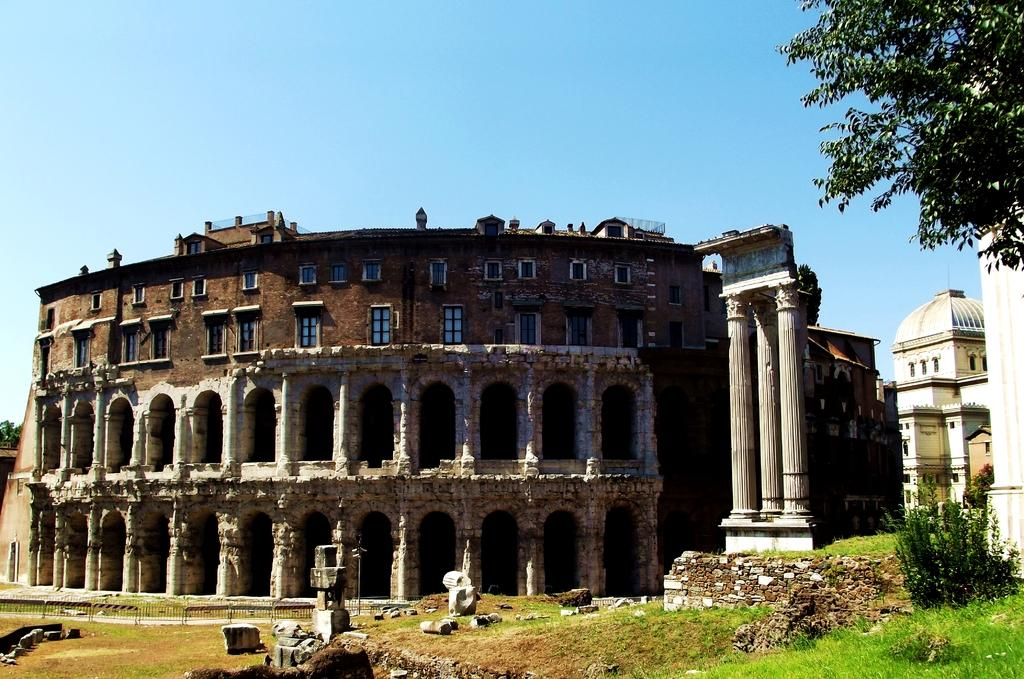What type of structures can be seen in the image? There are buildings in the image. What architectural elements are present in the image? There are pillars in the image. What type of vegetation is visible in the image? There are trees, plants, and grass in the image. What type of barrier is present in the image? There is a fence in the image. What type of ground cover is present in the image? There are stones and objects on the ground in the image. What can be seen in the background of the image? The sky is visible in the background of the image. Can you see any cables hanging from the buildings in the image? There is no mention of cables in the image, so we cannot determine if any are present. Are there any bats flying around the trees in the image? There is no mention of bats in the image, so we cannot determine if any are present. 